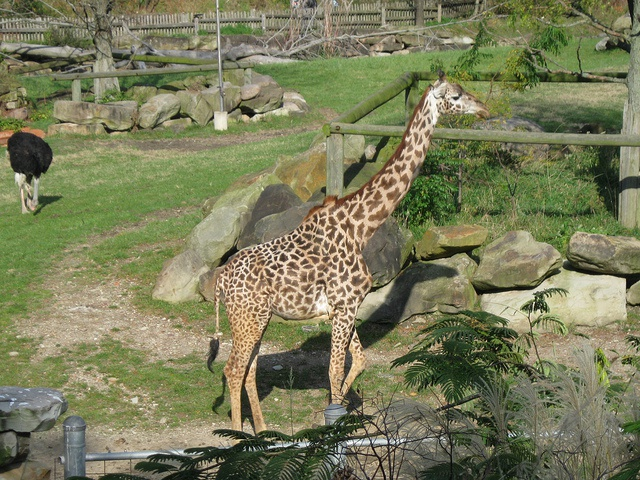Describe the objects in this image and their specific colors. I can see giraffe in olive, tan, and gray tones and bird in olive, black, darkgray, and tan tones in this image. 